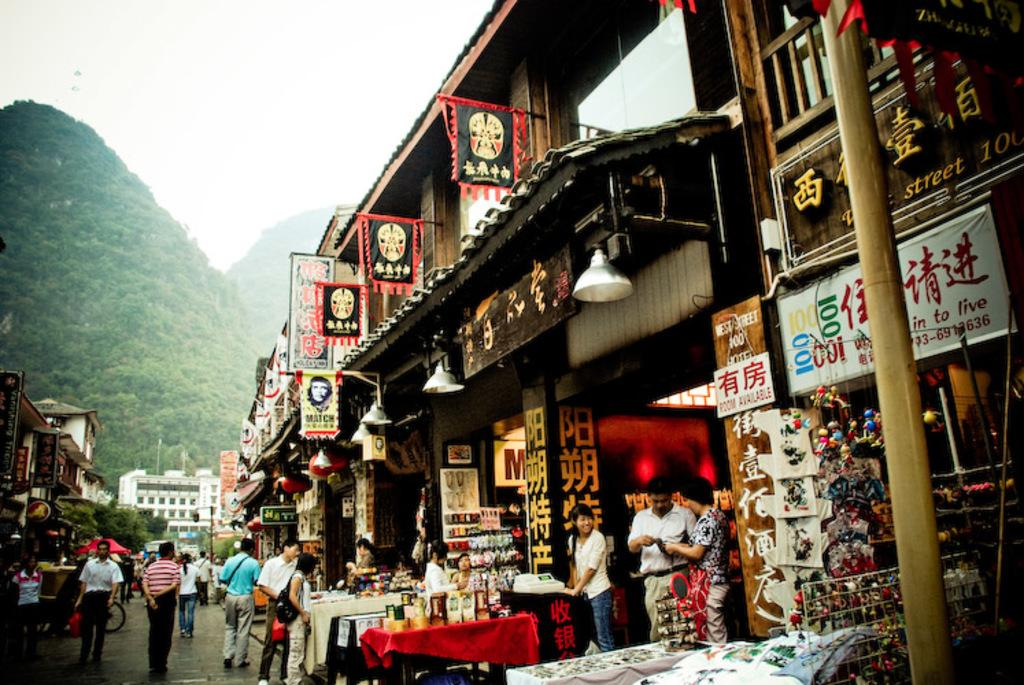<image>
Render a clear and concise summary of the photo. A busy asian market that has many goods and signs in Chinese lettering 